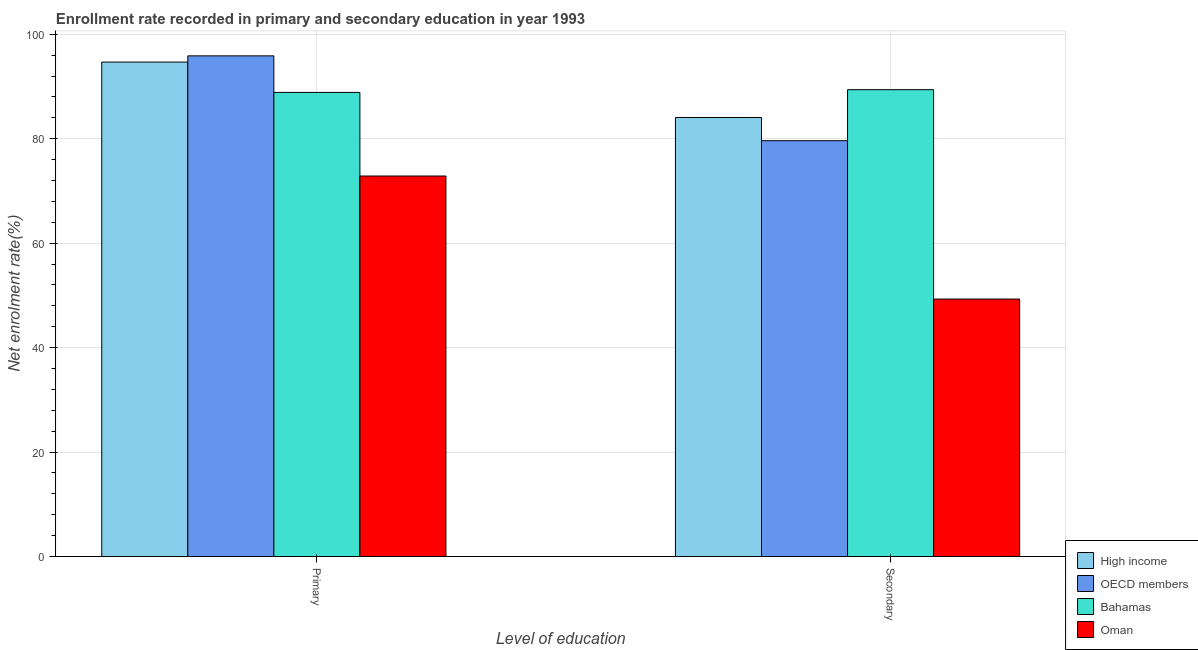How many groups of bars are there?
Make the answer very short. 2. Are the number of bars per tick equal to the number of legend labels?
Your answer should be very brief. Yes. How many bars are there on the 1st tick from the right?
Your answer should be very brief. 4. What is the label of the 1st group of bars from the left?
Keep it short and to the point. Primary. What is the enrollment rate in secondary education in High income?
Provide a short and direct response. 84.07. Across all countries, what is the maximum enrollment rate in secondary education?
Keep it short and to the point. 89.4. Across all countries, what is the minimum enrollment rate in primary education?
Offer a very short reply. 72.87. In which country was the enrollment rate in secondary education maximum?
Your response must be concise. Bahamas. In which country was the enrollment rate in primary education minimum?
Ensure brevity in your answer.  Oman. What is the total enrollment rate in secondary education in the graph?
Your answer should be compact. 302.4. What is the difference between the enrollment rate in primary education in Bahamas and that in Oman?
Your response must be concise. 16.01. What is the difference between the enrollment rate in primary education in Oman and the enrollment rate in secondary education in OECD members?
Ensure brevity in your answer.  -6.76. What is the average enrollment rate in primary education per country?
Provide a short and direct response. 88.08. What is the difference between the enrollment rate in primary education and enrollment rate in secondary education in High income?
Offer a terse response. 10.61. What is the ratio of the enrollment rate in primary education in OECD members to that in High income?
Make the answer very short. 1.01. What does the 1st bar from the right in Secondary represents?
Offer a very short reply. Oman. How many bars are there?
Make the answer very short. 8. Are all the bars in the graph horizontal?
Ensure brevity in your answer.  No. How many countries are there in the graph?
Offer a terse response. 4. What is the difference between two consecutive major ticks on the Y-axis?
Your response must be concise. 20. Are the values on the major ticks of Y-axis written in scientific E-notation?
Offer a terse response. No. Does the graph contain any zero values?
Provide a short and direct response. No. Does the graph contain grids?
Provide a succinct answer. Yes. How are the legend labels stacked?
Your answer should be compact. Vertical. What is the title of the graph?
Offer a very short reply. Enrollment rate recorded in primary and secondary education in year 1993. Does "Uzbekistan" appear as one of the legend labels in the graph?
Provide a succinct answer. No. What is the label or title of the X-axis?
Offer a terse response. Level of education. What is the label or title of the Y-axis?
Your answer should be very brief. Net enrolment rate(%). What is the Net enrolment rate(%) in High income in Primary?
Your answer should be very brief. 94.68. What is the Net enrolment rate(%) in OECD members in Primary?
Your answer should be compact. 95.88. What is the Net enrolment rate(%) of Bahamas in Primary?
Your answer should be very brief. 88.88. What is the Net enrolment rate(%) in Oman in Primary?
Provide a succinct answer. 72.87. What is the Net enrolment rate(%) in High income in Secondary?
Offer a terse response. 84.07. What is the Net enrolment rate(%) in OECD members in Secondary?
Provide a short and direct response. 79.63. What is the Net enrolment rate(%) in Bahamas in Secondary?
Your answer should be very brief. 89.4. What is the Net enrolment rate(%) in Oman in Secondary?
Give a very brief answer. 49.3. Across all Level of education, what is the maximum Net enrolment rate(%) in High income?
Offer a very short reply. 94.68. Across all Level of education, what is the maximum Net enrolment rate(%) of OECD members?
Keep it short and to the point. 95.88. Across all Level of education, what is the maximum Net enrolment rate(%) of Bahamas?
Your answer should be very brief. 89.4. Across all Level of education, what is the maximum Net enrolment rate(%) of Oman?
Offer a terse response. 72.87. Across all Level of education, what is the minimum Net enrolment rate(%) of High income?
Offer a very short reply. 84.07. Across all Level of education, what is the minimum Net enrolment rate(%) in OECD members?
Provide a succinct answer. 79.63. Across all Level of education, what is the minimum Net enrolment rate(%) of Bahamas?
Your response must be concise. 88.88. Across all Level of education, what is the minimum Net enrolment rate(%) in Oman?
Offer a terse response. 49.3. What is the total Net enrolment rate(%) in High income in the graph?
Provide a succinct answer. 178.75. What is the total Net enrolment rate(%) in OECD members in the graph?
Offer a terse response. 175.51. What is the total Net enrolment rate(%) of Bahamas in the graph?
Ensure brevity in your answer.  178.27. What is the total Net enrolment rate(%) in Oman in the graph?
Provide a succinct answer. 122.17. What is the difference between the Net enrolment rate(%) of High income in Primary and that in Secondary?
Provide a succinct answer. 10.61. What is the difference between the Net enrolment rate(%) in OECD members in Primary and that in Secondary?
Your response must be concise. 16.25. What is the difference between the Net enrolment rate(%) in Bahamas in Primary and that in Secondary?
Keep it short and to the point. -0.52. What is the difference between the Net enrolment rate(%) in Oman in Primary and that in Secondary?
Your answer should be very brief. 23.56. What is the difference between the Net enrolment rate(%) of High income in Primary and the Net enrolment rate(%) of OECD members in Secondary?
Your answer should be very brief. 15.05. What is the difference between the Net enrolment rate(%) in High income in Primary and the Net enrolment rate(%) in Bahamas in Secondary?
Offer a very short reply. 5.29. What is the difference between the Net enrolment rate(%) of High income in Primary and the Net enrolment rate(%) of Oman in Secondary?
Ensure brevity in your answer.  45.38. What is the difference between the Net enrolment rate(%) in OECD members in Primary and the Net enrolment rate(%) in Bahamas in Secondary?
Make the answer very short. 6.48. What is the difference between the Net enrolment rate(%) in OECD members in Primary and the Net enrolment rate(%) in Oman in Secondary?
Ensure brevity in your answer.  46.57. What is the difference between the Net enrolment rate(%) in Bahamas in Primary and the Net enrolment rate(%) in Oman in Secondary?
Ensure brevity in your answer.  39.57. What is the average Net enrolment rate(%) of High income per Level of education?
Give a very brief answer. 89.38. What is the average Net enrolment rate(%) of OECD members per Level of education?
Make the answer very short. 87.75. What is the average Net enrolment rate(%) of Bahamas per Level of education?
Your answer should be compact. 89.14. What is the average Net enrolment rate(%) in Oman per Level of education?
Your answer should be very brief. 61.09. What is the difference between the Net enrolment rate(%) in High income and Net enrolment rate(%) in OECD members in Primary?
Give a very brief answer. -1.19. What is the difference between the Net enrolment rate(%) of High income and Net enrolment rate(%) of Bahamas in Primary?
Your answer should be very brief. 5.81. What is the difference between the Net enrolment rate(%) of High income and Net enrolment rate(%) of Oman in Primary?
Make the answer very short. 21.81. What is the difference between the Net enrolment rate(%) in OECD members and Net enrolment rate(%) in Bahamas in Primary?
Offer a very short reply. 7. What is the difference between the Net enrolment rate(%) in OECD members and Net enrolment rate(%) in Oman in Primary?
Offer a terse response. 23.01. What is the difference between the Net enrolment rate(%) of Bahamas and Net enrolment rate(%) of Oman in Primary?
Provide a succinct answer. 16.01. What is the difference between the Net enrolment rate(%) in High income and Net enrolment rate(%) in OECD members in Secondary?
Keep it short and to the point. 4.44. What is the difference between the Net enrolment rate(%) in High income and Net enrolment rate(%) in Bahamas in Secondary?
Your response must be concise. -5.32. What is the difference between the Net enrolment rate(%) in High income and Net enrolment rate(%) in Oman in Secondary?
Make the answer very short. 34.77. What is the difference between the Net enrolment rate(%) of OECD members and Net enrolment rate(%) of Bahamas in Secondary?
Your answer should be compact. -9.76. What is the difference between the Net enrolment rate(%) of OECD members and Net enrolment rate(%) of Oman in Secondary?
Offer a very short reply. 30.33. What is the difference between the Net enrolment rate(%) in Bahamas and Net enrolment rate(%) in Oman in Secondary?
Give a very brief answer. 40.09. What is the ratio of the Net enrolment rate(%) in High income in Primary to that in Secondary?
Make the answer very short. 1.13. What is the ratio of the Net enrolment rate(%) of OECD members in Primary to that in Secondary?
Your response must be concise. 1.2. What is the ratio of the Net enrolment rate(%) of Bahamas in Primary to that in Secondary?
Your answer should be compact. 0.99. What is the ratio of the Net enrolment rate(%) of Oman in Primary to that in Secondary?
Give a very brief answer. 1.48. What is the difference between the highest and the second highest Net enrolment rate(%) in High income?
Your answer should be very brief. 10.61. What is the difference between the highest and the second highest Net enrolment rate(%) of OECD members?
Make the answer very short. 16.25. What is the difference between the highest and the second highest Net enrolment rate(%) in Bahamas?
Give a very brief answer. 0.52. What is the difference between the highest and the second highest Net enrolment rate(%) of Oman?
Provide a short and direct response. 23.56. What is the difference between the highest and the lowest Net enrolment rate(%) in High income?
Make the answer very short. 10.61. What is the difference between the highest and the lowest Net enrolment rate(%) in OECD members?
Offer a terse response. 16.25. What is the difference between the highest and the lowest Net enrolment rate(%) in Bahamas?
Provide a succinct answer. 0.52. What is the difference between the highest and the lowest Net enrolment rate(%) in Oman?
Your response must be concise. 23.56. 